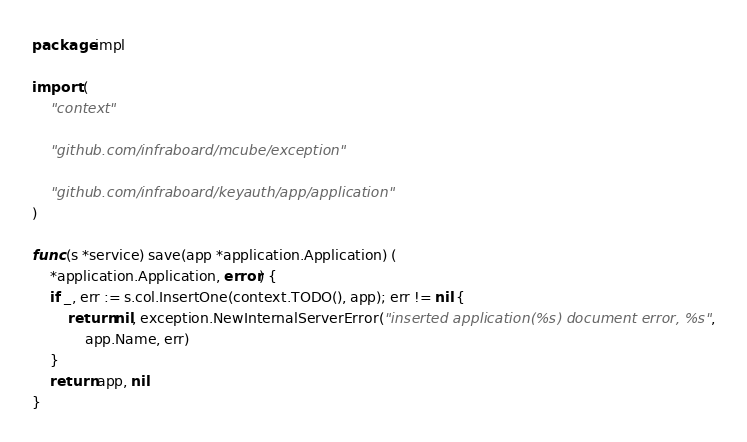Convert code to text. <code><loc_0><loc_0><loc_500><loc_500><_Go_>package impl

import (
	"context"

	"github.com/infraboard/mcube/exception"

	"github.com/infraboard/keyauth/app/application"
)

func (s *service) save(app *application.Application) (
	*application.Application, error) {
	if _, err := s.col.InsertOne(context.TODO(), app); err != nil {
		return nil, exception.NewInternalServerError("inserted application(%s) document error, %s",
			app.Name, err)
	}
	return app, nil
}
</code> 